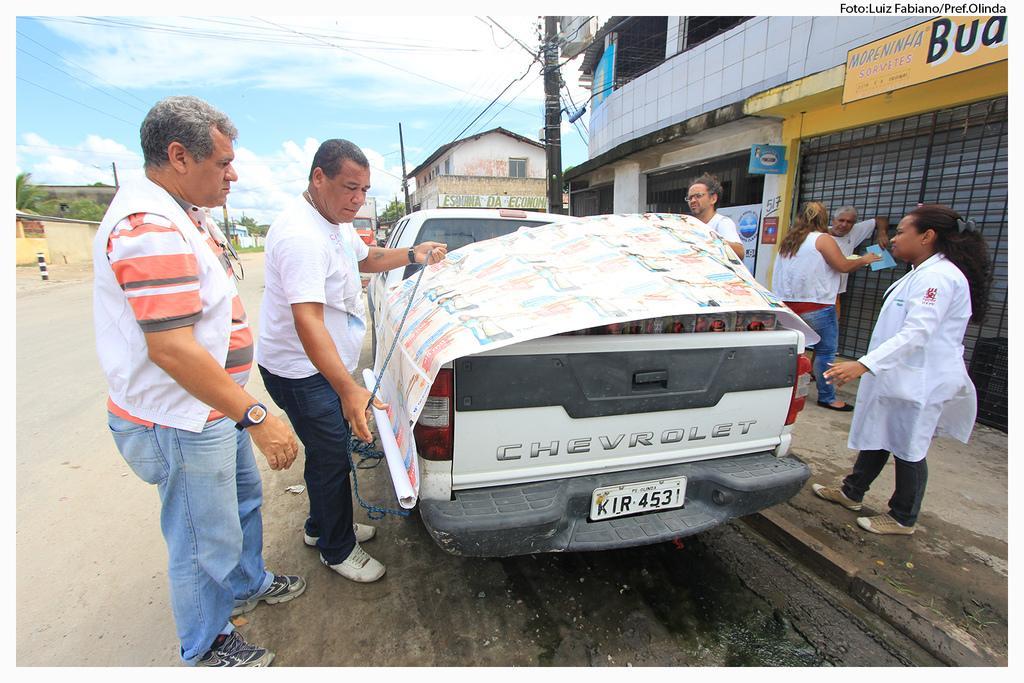Could you give a brief overview of what you see in this image? In this picture we can see a man wearing white t-shirt, standing near the car and holding the wrapping paper. Behind we can see shop grill and some people standing and discussing something. In the background we can see shed house. On the top we can see the sky and clouds. 